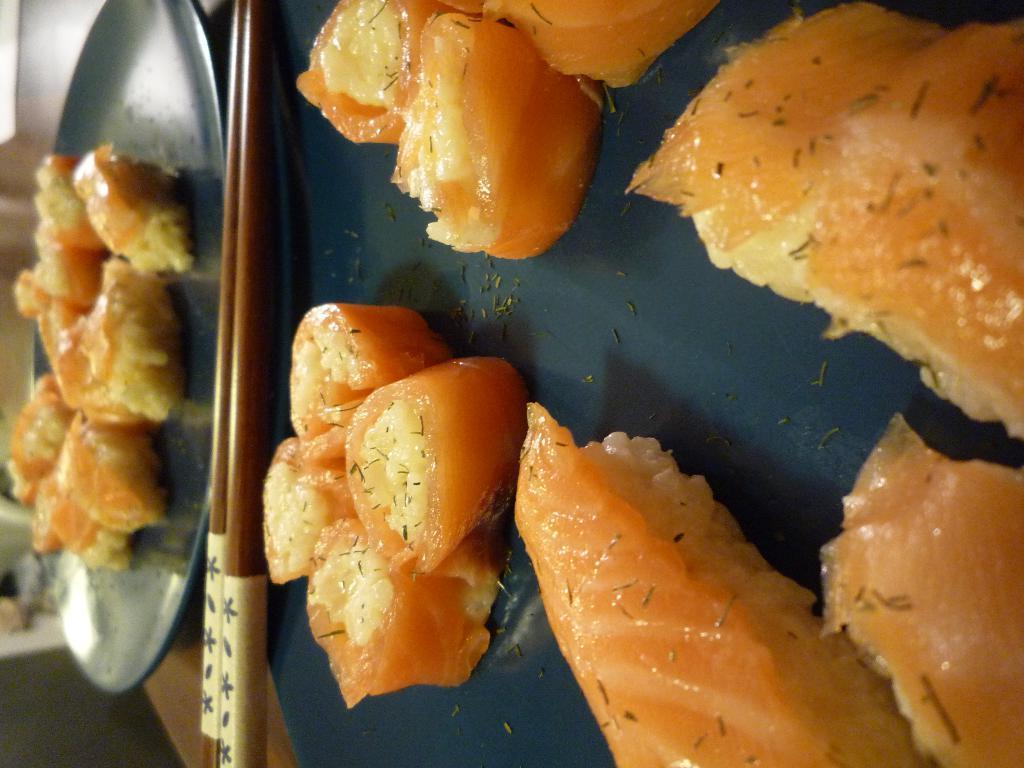Can you describe this image briefly? In this picture we can see chopsticks, plates with food items on it and these all are placed on a wooden surface and in the background we can see some objects. 